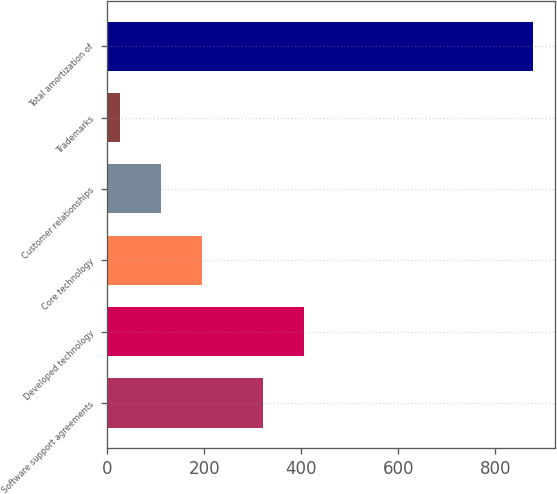Convert chart. <chart><loc_0><loc_0><loc_500><loc_500><bar_chart><fcel>Software support agreements<fcel>Developed technology<fcel>Core technology<fcel>Customer relationships<fcel>Trademarks<fcel>Total amortization of<nl><fcel>321<fcel>406.3<fcel>195.6<fcel>110.3<fcel>25<fcel>878<nl></chart> 